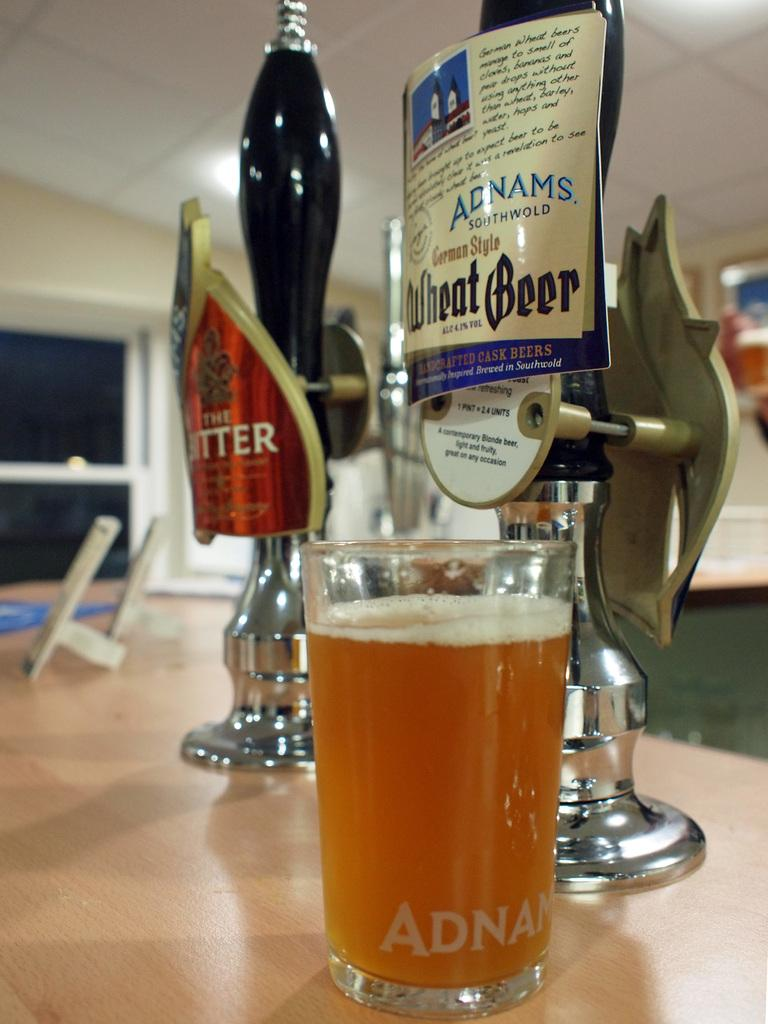Provide a one-sentence caption for the provided image. Glass of Adnams Wheat Beer in front of a tap. 